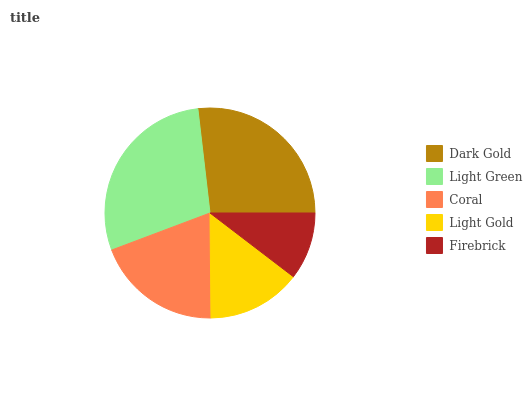Is Firebrick the minimum?
Answer yes or no. Yes. Is Light Green the maximum?
Answer yes or no. Yes. Is Coral the minimum?
Answer yes or no. No. Is Coral the maximum?
Answer yes or no. No. Is Light Green greater than Coral?
Answer yes or no. Yes. Is Coral less than Light Green?
Answer yes or no. Yes. Is Coral greater than Light Green?
Answer yes or no. No. Is Light Green less than Coral?
Answer yes or no. No. Is Coral the high median?
Answer yes or no. Yes. Is Coral the low median?
Answer yes or no. Yes. Is Light Gold the high median?
Answer yes or no. No. Is Light Green the low median?
Answer yes or no. No. 